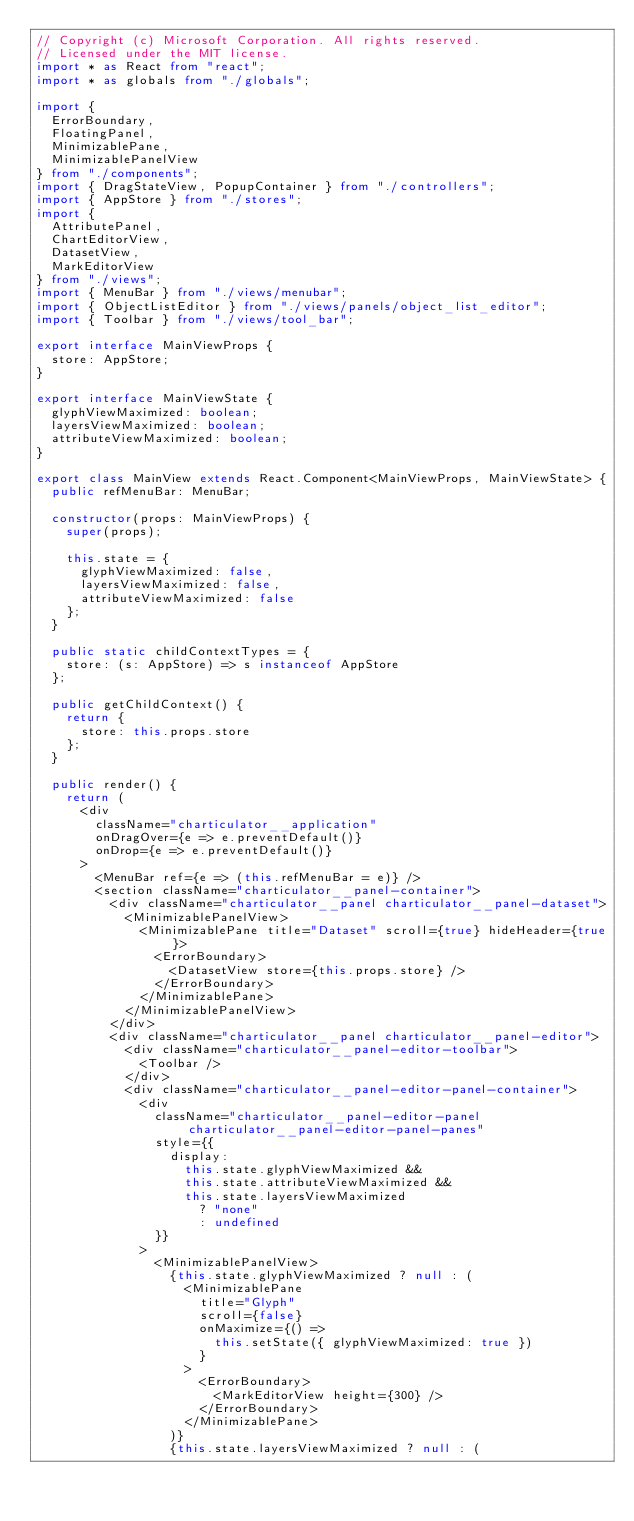<code> <loc_0><loc_0><loc_500><loc_500><_TypeScript_>// Copyright (c) Microsoft Corporation. All rights reserved.
// Licensed under the MIT license.
import * as React from "react";
import * as globals from "./globals";

import {
  ErrorBoundary,
  FloatingPanel,
  MinimizablePane,
  MinimizablePanelView
} from "./components";
import { DragStateView, PopupContainer } from "./controllers";
import { AppStore } from "./stores";
import {
  AttributePanel,
  ChartEditorView,
  DatasetView,
  MarkEditorView
} from "./views";
import { MenuBar } from "./views/menubar";
import { ObjectListEditor } from "./views/panels/object_list_editor";
import { Toolbar } from "./views/tool_bar";

export interface MainViewProps {
  store: AppStore;
}

export interface MainViewState {
  glyphViewMaximized: boolean;
  layersViewMaximized: boolean;
  attributeViewMaximized: boolean;
}

export class MainView extends React.Component<MainViewProps, MainViewState> {
  public refMenuBar: MenuBar;

  constructor(props: MainViewProps) {
    super(props);

    this.state = {
      glyphViewMaximized: false,
      layersViewMaximized: false,
      attributeViewMaximized: false
    };
  }

  public static childContextTypes = {
    store: (s: AppStore) => s instanceof AppStore
  };

  public getChildContext() {
    return {
      store: this.props.store
    };
  }

  public render() {
    return (
      <div
        className="charticulator__application"
        onDragOver={e => e.preventDefault()}
        onDrop={e => e.preventDefault()}
      >
        <MenuBar ref={e => (this.refMenuBar = e)} />
        <section className="charticulator__panel-container">
          <div className="charticulator__panel charticulator__panel-dataset">
            <MinimizablePanelView>
              <MinimizablePane title="Dataset" scroll={true} hideHeader={true}>
                <ErrorBoundary>
                  <DatasetView store={this.props.store} />
                </ErrorBoundary>
              </MinimizablePane>
            </MinimizablePanelView>
          </div>
          <div className="charticulator__panel charticulator__panel-editor">
            <div className="charticulator__panel-editor-toolbar">
              <Toolbar />
            </div>
            <div className="charticulator__panel-editor-panel-container">
              <div
                className="charticulator__panel-editor-panel charticulator__panel-editor-panel-panes"
                style={{
                  display:
                    this.state.glyphViewMaximized &&
                    this.state.attributeViewMaximized &&
                    this.state.layersViewMaximized
                      ? "none"
                      : undefined
                }}
              >
                <MinimizablePanelView>
                  {this.state.glyphViewMaximized ? null : (
                    <MinimizablePane
                      title="Glyph"
                      scroll={false}
                      onMaximize={() =>
                        this.setState({ glyphViewMaximized: true })
                      }
                    >
                      <ErrorBoundary>
                        <MarkEditorView height={300} />
                      </ErrorBoundary>
                    </MinimizablePane>
                  )}
                  {this.state.layersViewMaximized ? null : (</code> 